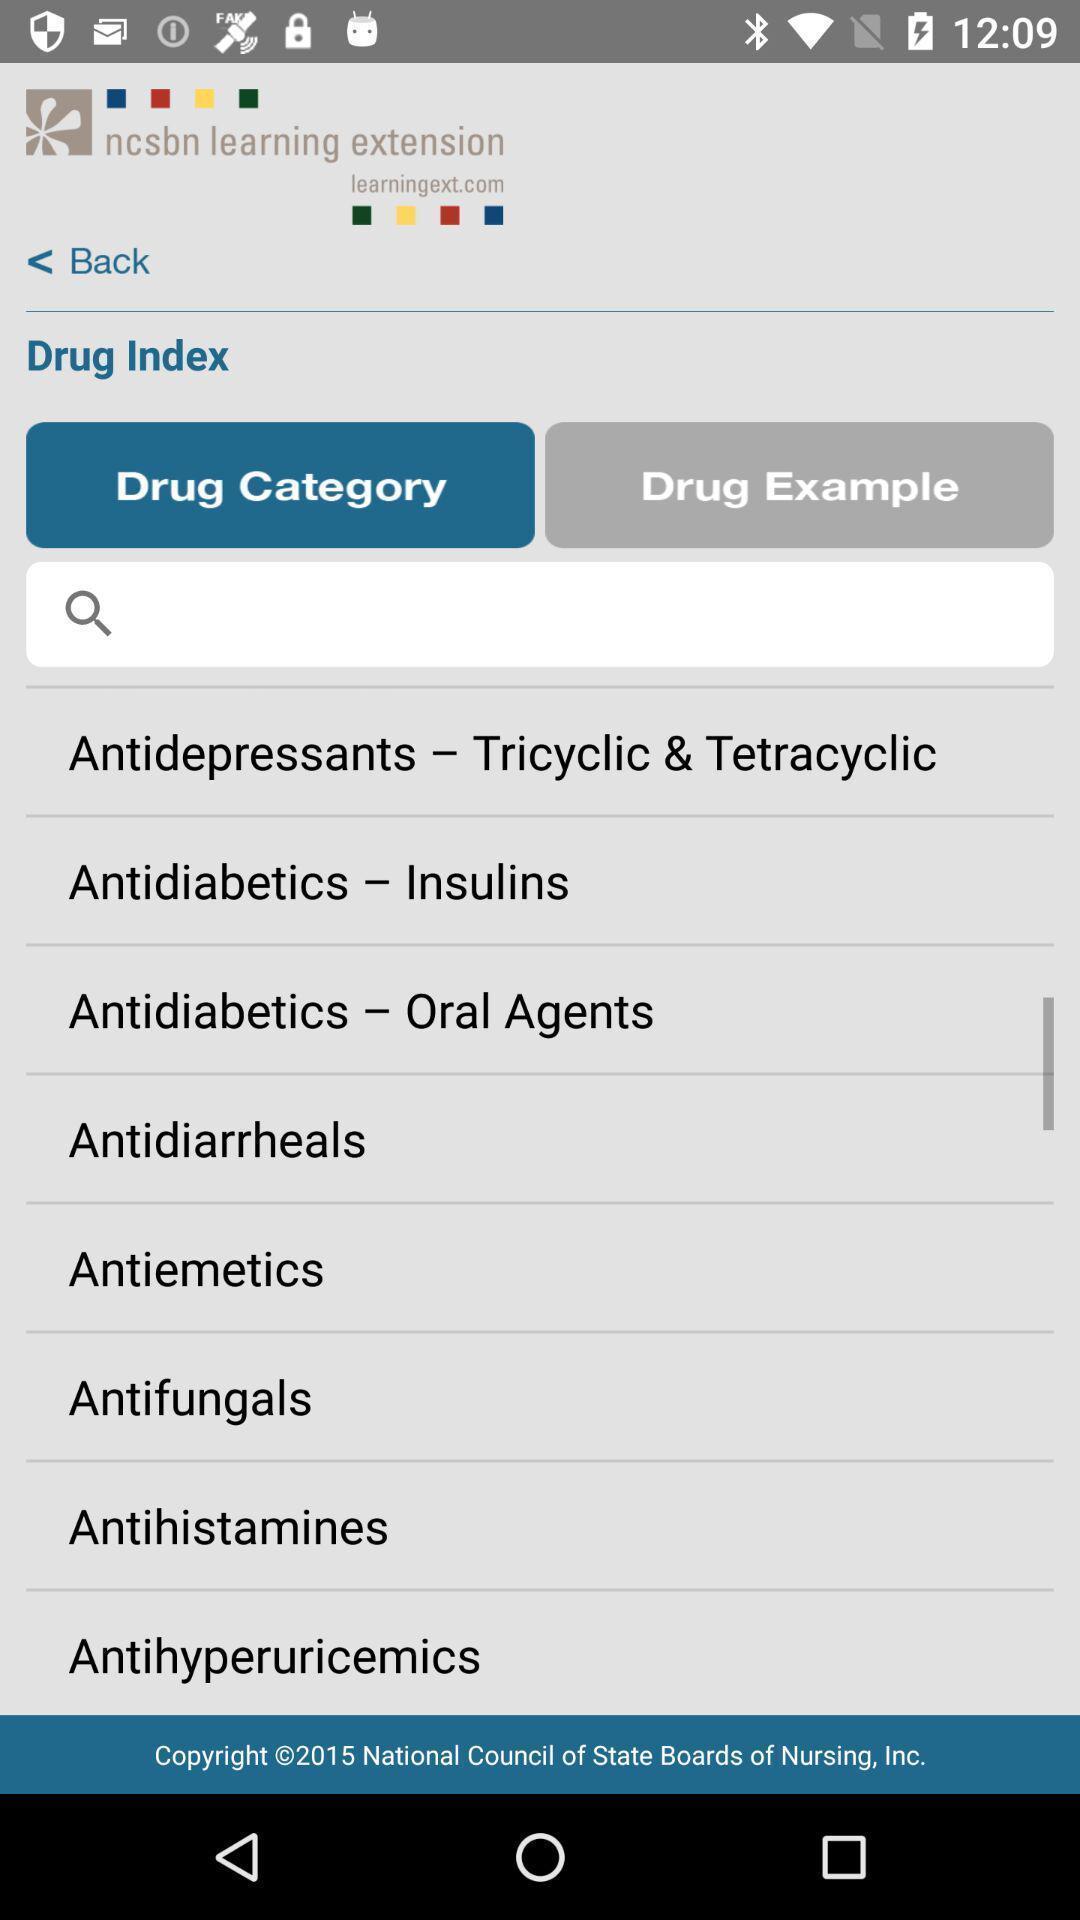Please provide a description for this image. Search bar to find different drug categories and names. 